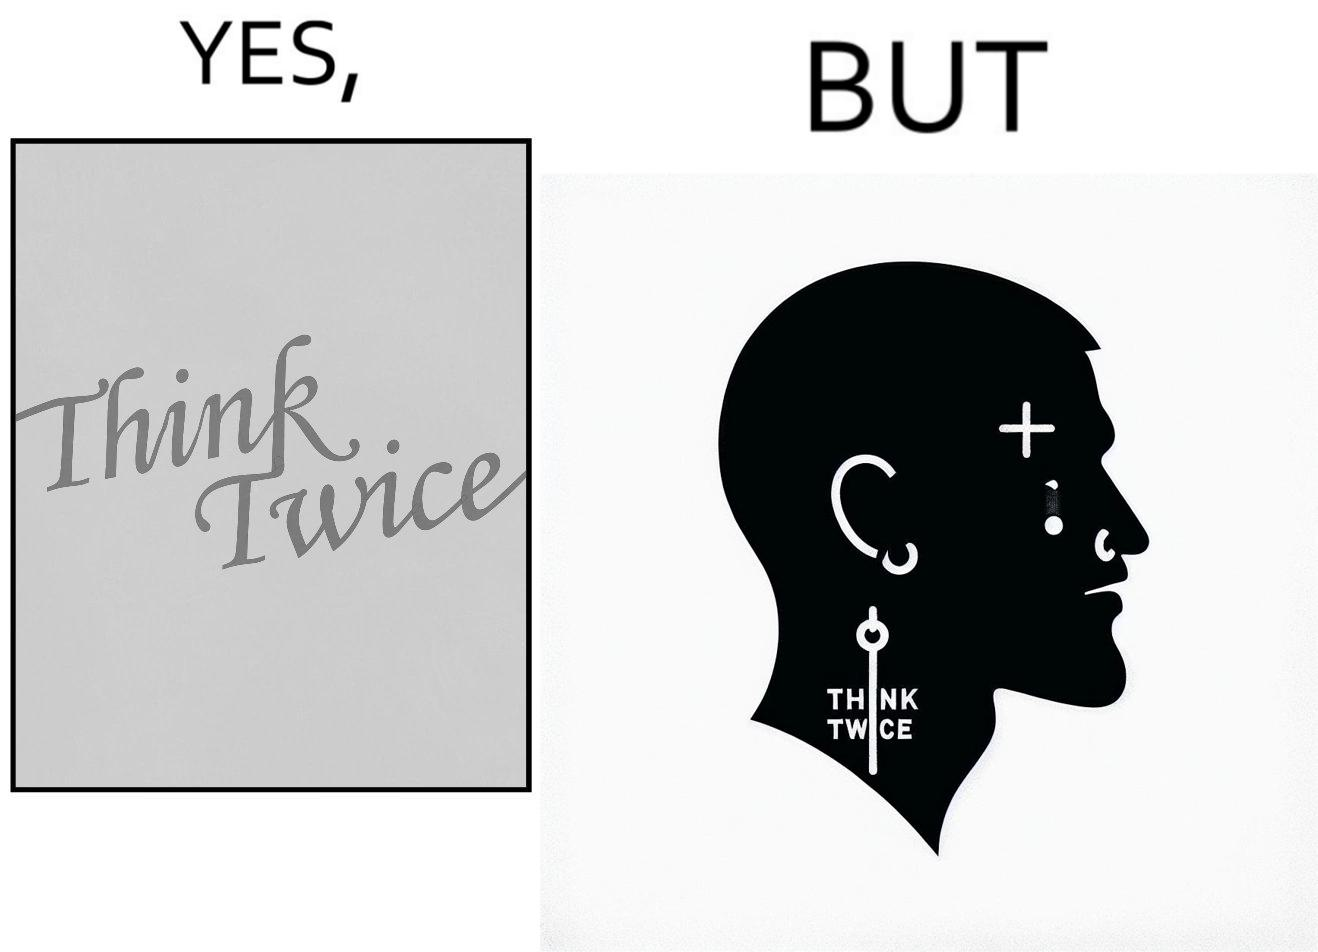Does this image contain satire or humor? Yes, this image is satirical. 